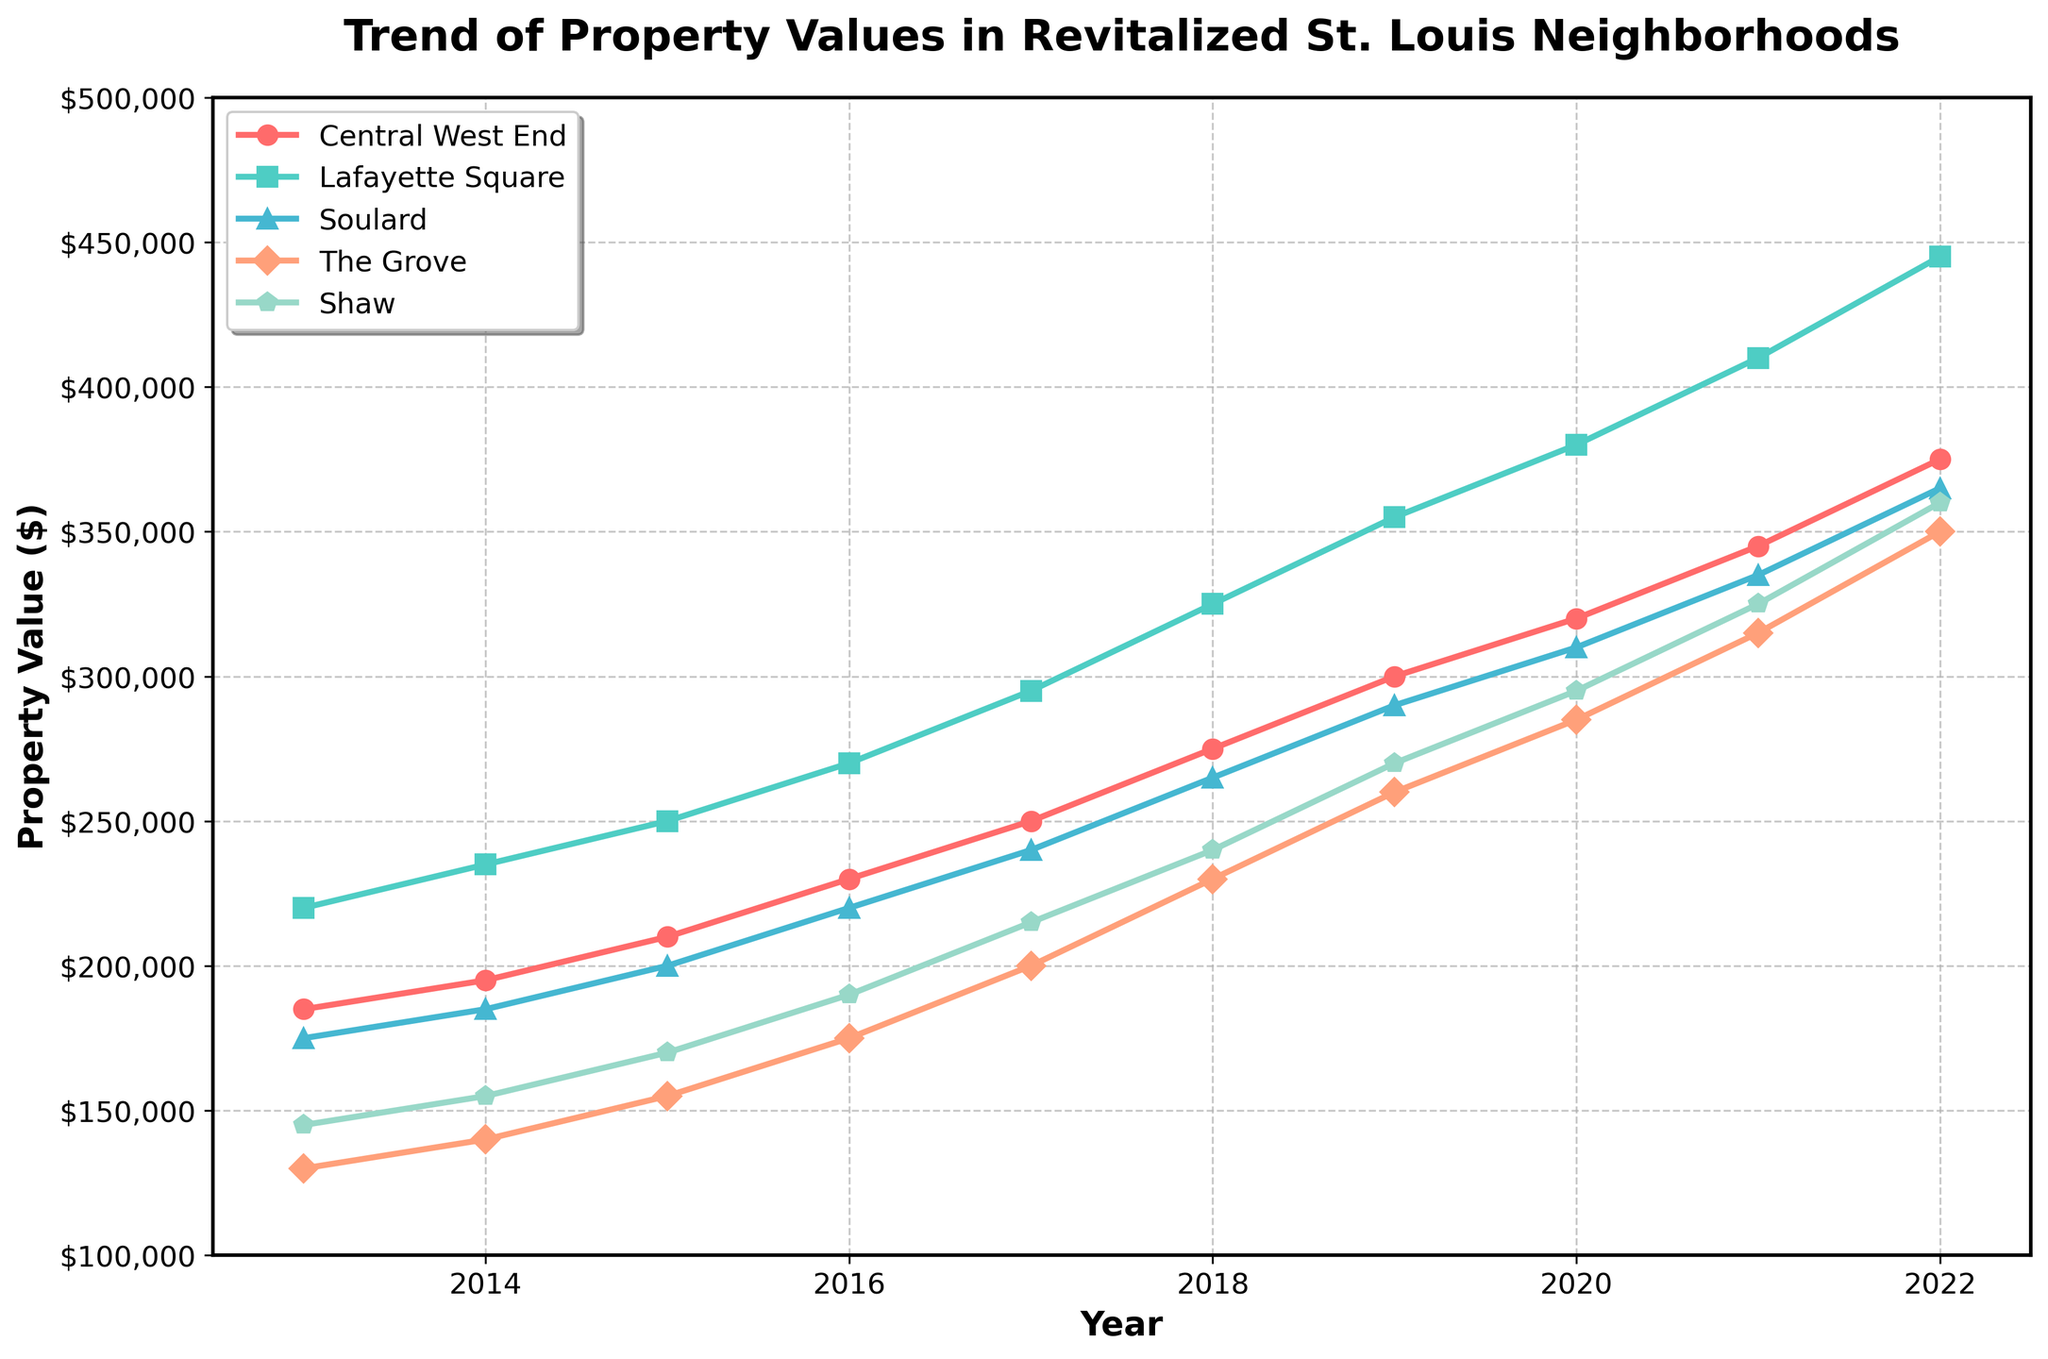How much did property values increase in the Central West End from 2013 to 2022? To find the increase, subtract the 2013 value (185000) from the 2022 value (375000). The increase is 375000 - 185000.
Answer: 190000 Which neighborhood had the highest property value in 2022? Compare the property values of all neighborhoods in 2022. Lafayette Square has the highest value at 445000.
Answer: Lafayette Square Between which years did The Grove have the sharpest increase in property value? Look for the year-to-year changes in The Grove's values and identify the largest increase. The sharpest increase is between 2017 (200000) and 2018 (230000).
Answer: 2017 to 2018 What is the average property value in Shaw across the decade? Sum the values for Shaw from 2013 to 2022, then divide by the number of years (10). The sum is 145000 + 155000 + 170000 + 190000 + 215000 + 240000 + 270000 + 295000 + 325000 + 360000 = 2265000. The average is 2265000 / 10.
Answer: 226500 How does the property value trend of Soulard compare with Central West End between 2013 and 2022? Both neighborhoods exhibit a general upward trend, but Soulard's values grew from 175000 to 365000, while Central West End's values grew from 185000 to 375000. Central West End had a larger increase.
Answer: Central West End had a larger increase In which year did Lafayette Square first surpass a property value of 300000? Identify the first year when Lafayette Square's property value exceeds 300000. It first surpasses in 2018 with a value of 325000.
Answer: 2018 What is the median property value for Soulard over the given period? List Soulard's values in ascending order: 175000, 185000, 200000, 220000, 240000, 265000, 290000, 310000, 335000, 365000. The median is the average of the 5th and 6th values: (240000 + 265000) / 2.
Answer: 252500 Which neighborhood showed the least growth in property value over the decade? Calculate the growth for each neighborhood: Central West End (190000), Lafayette Square (225000), Soulard (190000), The Grove (220000), Shaw (215000). Soulard shows the least growth.
Answer: Soulard What was the property value in The Grove in 2016, and how much more was it in 2020? The property value in The Grove in 2016 was 175000, and in 2020 it was 285000. The increase is 285000 - 175000.
Answer: 110000 Which neighborhoods had a property value above 300000 in 2020? Identify neighborhoods with values above 300000 in 2020: Central West End (320000), Lafayette Square (380000), and Soulard (310000).
Answer: Central West End, Lafayette Square, and Soulard 